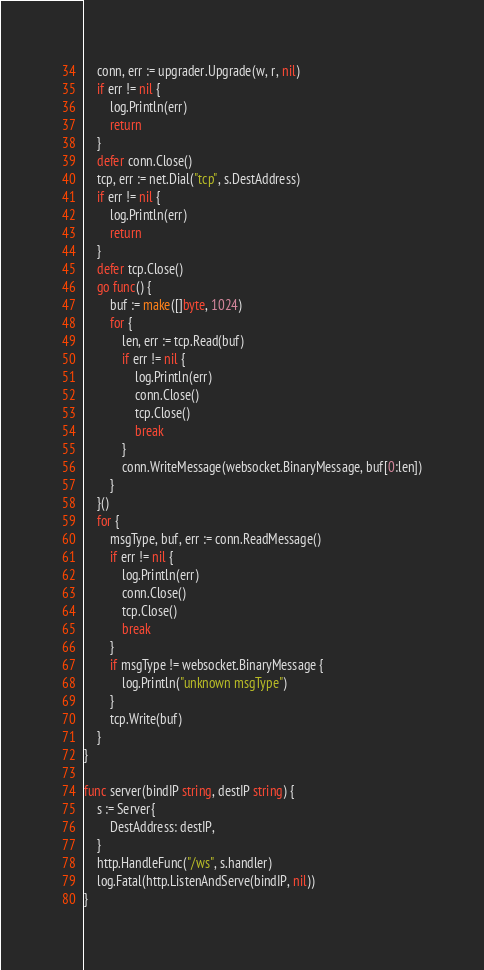<code> <loc_0><loc_0><loc_500><loc_500><_Go_>	conn, err := upgrader.Upgrade(w, r, nil)
	if err != nil {
		log.Println(err)
		return
	}
	defer conn.Close()
	tcp, err := net.Dial("tcp", s.DestAddress)
	if err != nil {
		log.Println(err)
		return
	}
	defer tcp.Close()
	go func() {
		buf := make([]byte, 1024)
		for {
			len, err := tcp.Read(buf)
			if err != nil {
				log.Println(err)
				conn.Close()
				tcp.Close()
				break
			}
			conn.WriteMessage(websocket.BinaryMessage, buf[0:len])
		}
	}()
	for {
		msgType, buf, err := conn.ReadMessage()
		if err != nil {
			log.Println(err)
			conn.Close()
			tcp.Close()
			break
		}
		if msgType != websocket.BinaryMessage {
			log.Println("unknown msgType")
		}
		tcp.Write(buf)
	}
}

func server(bindIP string, destIP string) {
	s := Server{
		DestAddress: destIP,
	}
	http.HandleFunc("/ws", s.handler)
	log.Fatal(http.ListenAndServe(bindIP, nil))
}
</code> 